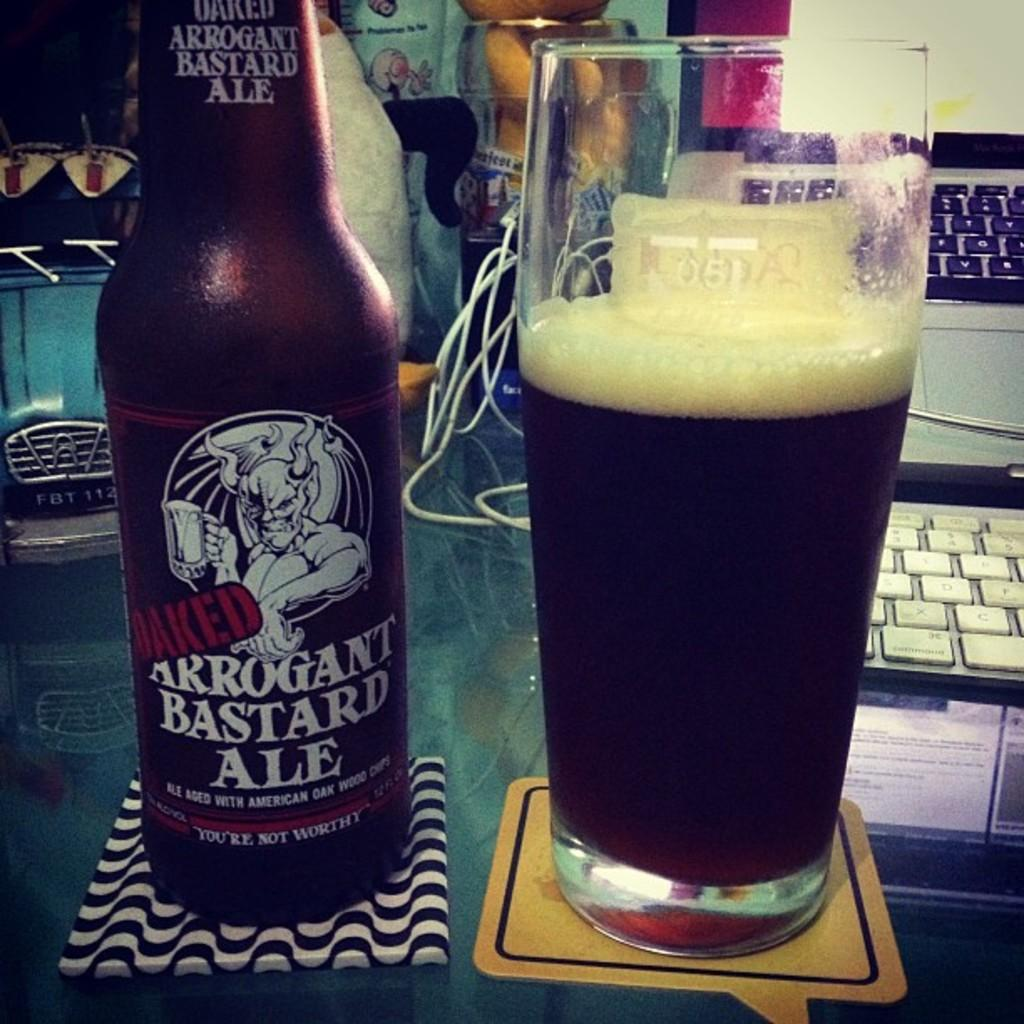Provide a one-sentence caption for the provided image. Arrogant Bastard Ale aged with American Oak Wood and a tall beer glass. 